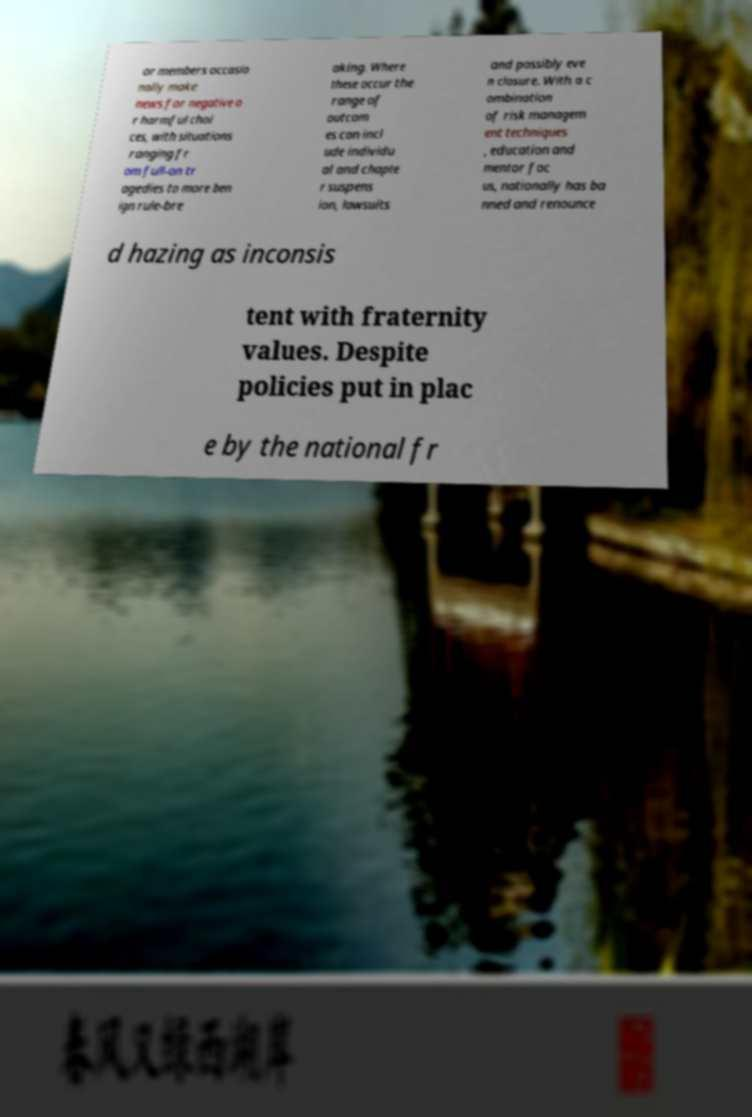Could you extract and type out the text from this image? or members occasio nally make news for negative o r harmful choi ces, with situations ranging fr om full-on tr agedies to more ben ign rule-bre aking. Where these occur the range of outcom es can incl ude individu al and chapte r suspens ion, lawsuits and possibly eve n closure. With a c ombination of risk managem ent techniques , education and mentor foc us, nationally has ba nned and renounce d hazing as inconsis tent with fraternity values. Despite policies put in plac e by the national fr 